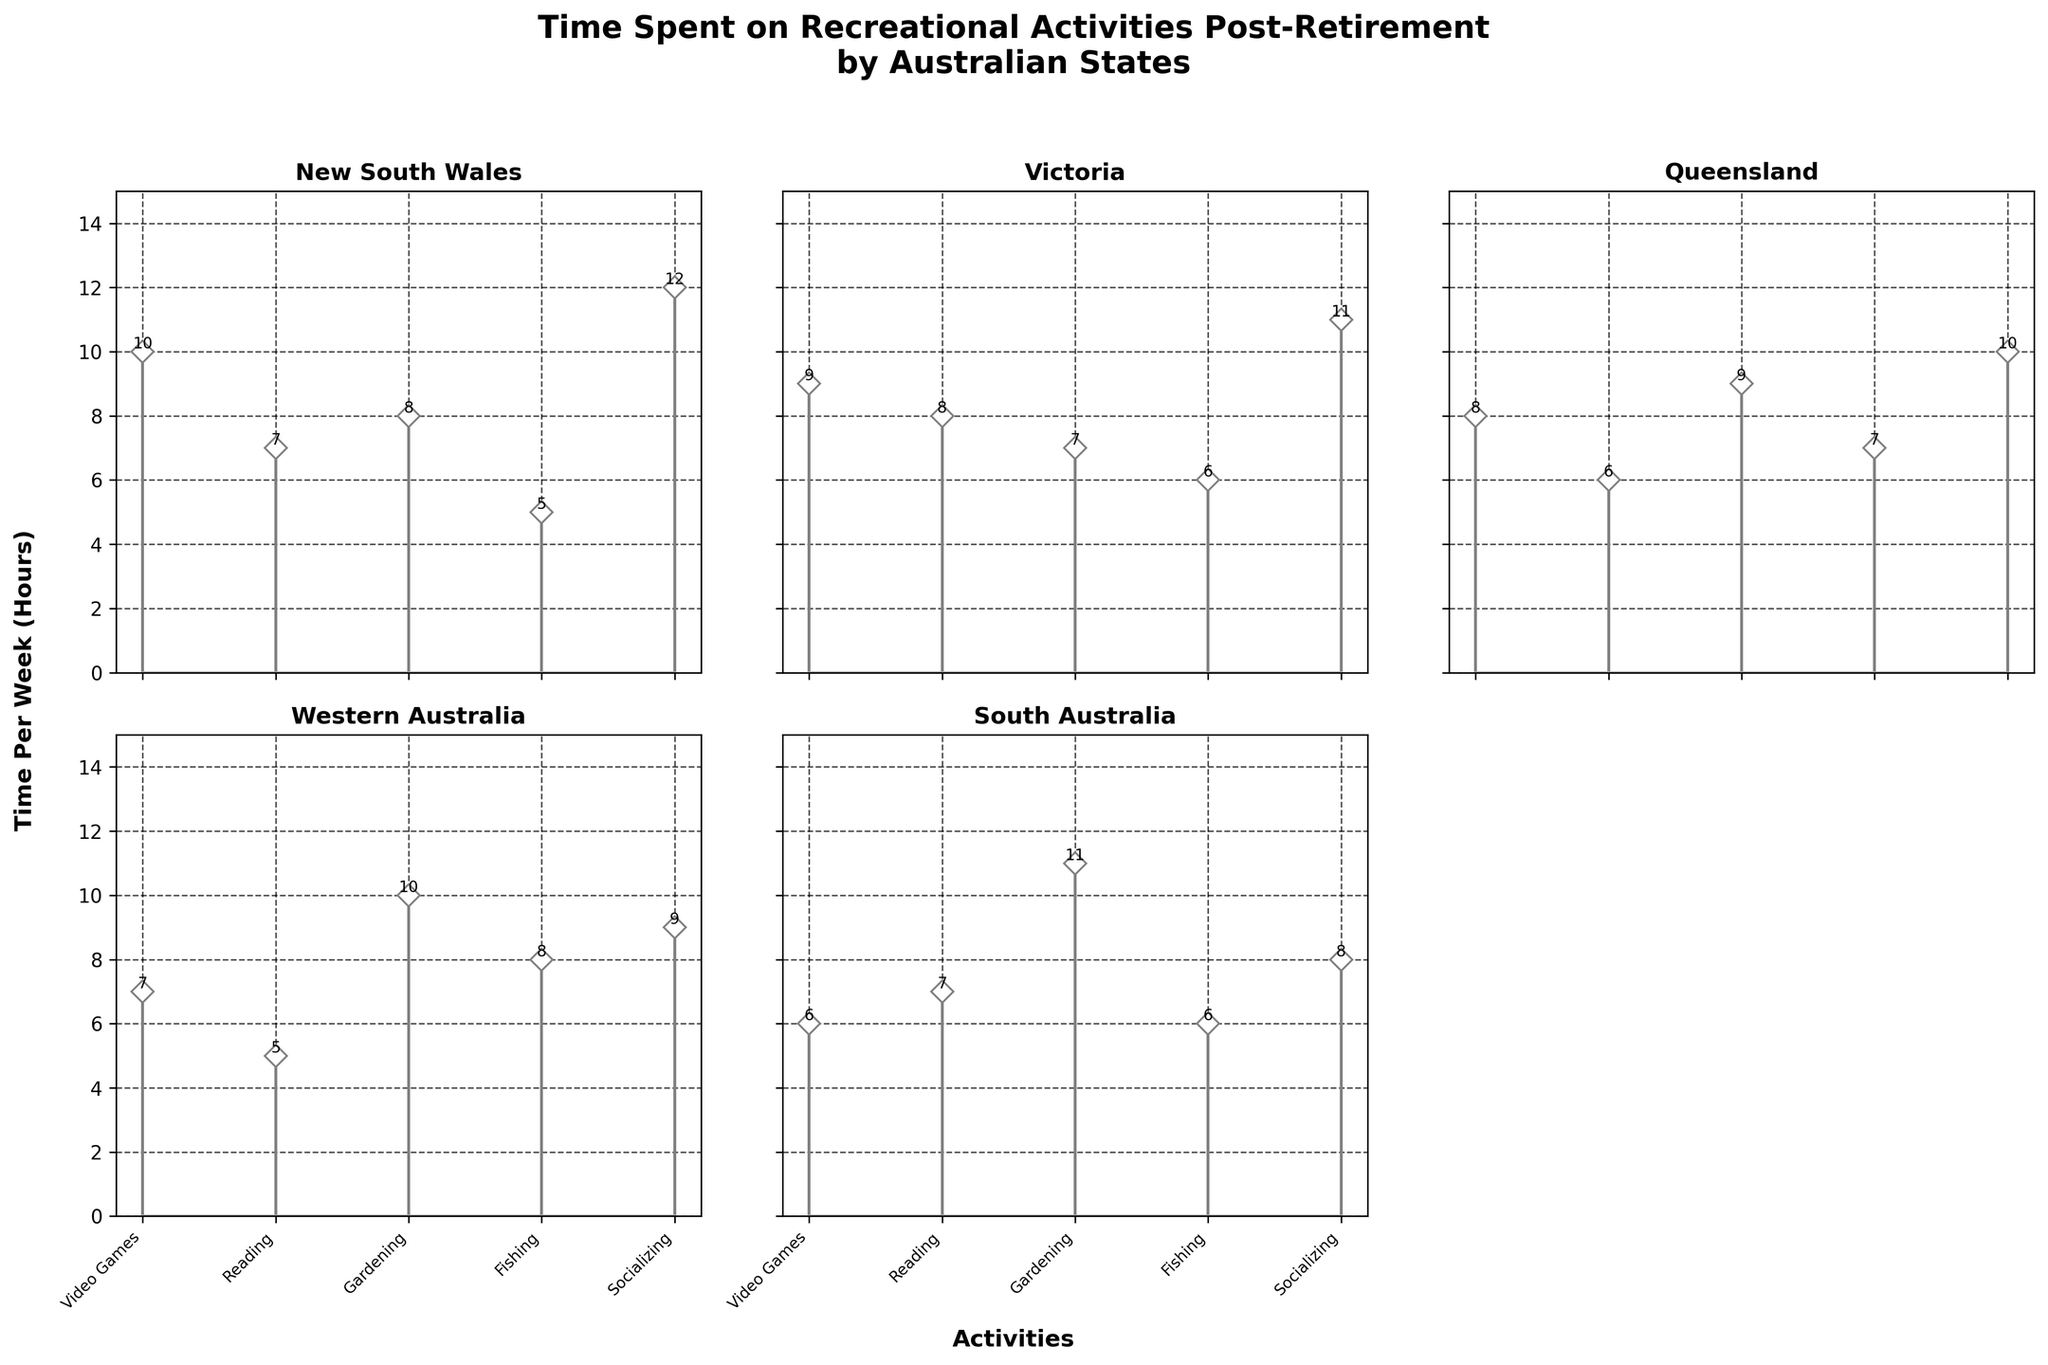What is the title of the figure? The title of the figure is typically positioned at the top center and often written in a larger or bold font. Here, it states that this chart shows the time spent on recreational activities post-retirement by different Australian states.
Answer: Time Spent on Recreational Activities Post-Retirement by Australian States How many activities are compared across states? By looking at the x-axis labels of any subplot, there are five distinct activities listed: Video Games, Reading, Gardening, Fishing, and Socializing.
Answer: 5 Which state spends the most time socializing? By comparing the heights of the "Socializing" bars in each subplot, we can see which one is the tallest. For "Socializing," New South Wales has the highest value of 12 hours per week.
Answer: New South Wales What is the least time-consuming activity in Queensland? By observing the stem heights in the Queensland subplot, the shortest stem provides the answer. Here, the "Reading" activity stem is the shortest with a time of 6 hours.
Answer: Reading Calculate the average time spent on Video Games across all states. First, sum the values of the "Video Games" stems across all subplots: 10 (NSW) + 9 (Victoria) + 8 (Queensland) + 7 (Western Australia) + 6 (South Australia). This gives 40. Dividing by the number of states (5) gives the average.
Answer: 8 In which state does "Gardening" have the highest time spent? We compare "Gardening" times in all subplots and find that South Australia has the maximum value of 11 hours per week.
Answer: South Australia Which activity shows the smallest range of time among states? To find the activity with the smallest range, calculate the difference between the maximum and minimum values for each activity across the states. "Video Games" ranges from 6 to 10 (range 4), "Reading" ranges from 5 to 8 (range 3), "Gardening" ranges from 7 to 11 (range 4), "Fishing" ranges from 5 to 8 (range 3), and "Socializing" ranges from 8 to 12 (range 4). The smallest range is found for "Reading" and "Fishing."
Answer: Reading and Fishing Compare the number of hours spent on Gardening between New South Wales and Western Australia. Which is higher and by how many hours? New South Wales spends 8 hours on Gardening, and Western Australia spends 10 hours. Subtracting 8 from 10 gives the difference.
Answer: Western Australia by 2 hours Identify which state has the most balanced (similar) distribution of time spent across all activities. We look for the subplot where the heights of all stems are roughly the same. Western Australia appears the most balanced, with values close to each other ranging between 5 to 10 hours.
Answer: Western Australia 